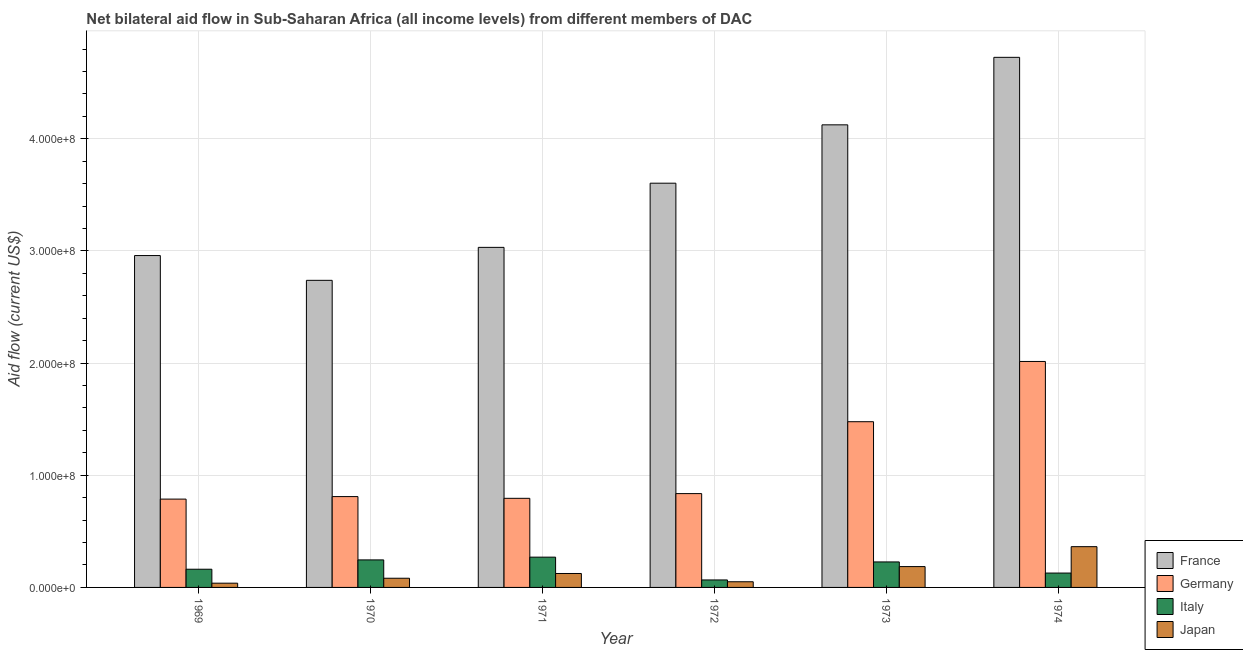How many groups of bars are there?
Provide a succinct answer. 6. Are the number of bars on each tick of the X-axis equal?
Give a very brief answer. Yes. How many bars are there on the 2nd tick from the left?
Ensure brevity in your answer.  4. What is the amount of aid given by germany in 1972?
Offer a terse response. 8.36e+07. Across all years, what is the maximum amount of aid given by japan?
Your answer should be very brief. 3.64e+07. Across all years, what is the minimum amount of aid given by japan?
Provide a succinct answer. 3.79e+06. In which year was the amount of aid given by germany maximum?
Give a very brief answer. 1974. In which year was the amount of aid given by italy minimum?
Keep it short and to the point. 1972. What is the total amount of aid given by germany in the graph?
Your answer should be compact. 6.72e+08. What is the difference between the amount of aid given by germany in 1972 and that in 1973?
Your answer should be compact. -6.41e+07. What is the difference between the amount of aid given by italy in 1971 and the amount of aid given by japan in 1970?
Your answer should be compact. 2.46e+06. What is the average amount of aid given by italy per year?
Provide a short and direct response. 1.83e+07. In the year 1969, what is the difference between the amount of aid given by italy and amount of aid given by germany?
Keep it short and to the point. 0. What is the ratio of the amount of aid given by italy in 1969 to that in 1970?
Provide a short and direct response. 0.66. Is the amount of aid given by france in 1970 less than that in 1972?
Give a very brief answer. Yes. What is the difference between the highest and the second highest amount of aid given by france?
Give a very brief answer. 6.02e+07. What is the difference between the highest and the lowest amount of aid given by japan?
Your response must be concise. 3.26e+07. In how many years, is the amount of aid given by italy greater than the average amount of aid given by italy taken over all years?
Provide a succinct answer. 3. What does the 3rd bar from the right in 1972 represents?
Your response must be concise. Germany. What is the difference between two consecutive major ticks on the Y-axis?
Your response must be concise. 1.00e+08. Are the values on the major ticks of Y-axis written in scientific E-notation?
Keep it short and to the point. Yes. Does the graph contain any zero values?
Offer a terse response. No. Where does the legend appear in the graph?
Your answer should be compact. Bottom right. How are the legend labels stacked?
Offer a very short reply. Vertical. What is the title of the graph?
Your response must be concise. Net bilateral aid flow in Sub-Saharan Africa (all income levels) from different members of DAC. Does "Fish species" appear as one of the legend labels in the graph?
Keep it short and to the point. No. What is the Aid flow (current US$) in France in 1969?
Make the answer very short. 2.96e+08. What is the Aid flow (current US$) in Germany in 1969?
Your answer should be compact. 7.88e+07. What is the Aid flow (current US$) of Italy in 1969?
Your response must be concise. 1.62e+07. What is the Aid flow (current US$) of Japan in 1969?
Provide a short and direct response. 3.79e+06. What is the Aid flow (current US$) of France in 1970?
Provide a short and direct response. 2.74e+08. What is the Aid flow (current US$) of Germany in 1970?
Keep it short and to the point. 8.10e+07. What is the Aid flow (current US$) in Italy in 1970?
Keep it short and to the point. 2.45e+07. What is the Aid flow (current US$) in Japan in 1970?
Your answer should be very brief. 8.19e+06. What is the Aid flow (current US$) of France in 1971?
Your answer should be very brief. 3.03e+08. What is the Aid flow (current US$) of Germany in 1971?
Ensure brevity in your answer.  7.94e+07. What is the Aid flow (current US$) in Italy in 1971?
Offer a very short reply. 2.70e+07. What is the Aid flow (current US$) in Japan in 1971?
Provide a succinct answer. 1.24e+07. What is the Aid flow (current US$) of France in 1972?
Provide a short and direct response. 3.60e+08. What is the Aid flow (current US$) in Germany in 1972?
Your response must be concise. 8.36e+07. What is the Aid flow (current US$) of Italy in 1972?
Your response must be concise. 6.67e+06. What is the Aid flow (current US$) in Japan in 1972?
Offer a terse response. 5.05e+06. What is the Aid flow (current US$) of France in 1973?
Your answer should be compact. 4.12e+08. What is the Aid flow (current US$) of Germany in 1973?
Give a very brief answer. 1.48e+08. What is the Aid flow (current US$) in Italy in 1973?
Make the answer very short. 2.27e+07. What is the Aid flow (current US$) in Japan in 1973?
Ensure brevity in your answer.  1.86e+07. What is the Aid flow (current US$) of France in 1974?
Ensure brevity in your answer.  4.73e+08. What is the Aid flow (current US$) in Germany in 1974?
Your answer should be very brief. 2.01e+08. What is the Aid flow (current US$) in Italy in 1974?
Your answer should be compact. 1.28e+07. What is the Aid flow (current US$) in Japan in 1974?
Provide a short and direct response. 3.64e+07. Across all years, what is the maximum Aid flow (current US$) of France?
Give a very brief answer. 4.73e+08. Across all years, what is the maximum Aid flow (current US$) of Germany?
Provide a succinct answer. 2.01e+08. Across all years, what is the maximum Aid flow (current US$) in Italy?
Your response must be concise. 2.70e+07. Across all years, what is the maximum Aid flow (current US$) of Japan?
Your response must be concise. 3.64e+07. Across all years, what is the minimum Aid flow (current US$) in France?
Give a very brief answer. 2.74e+08. Across all years, what is the minimum Aid flow (current US$) in Germany?
Ensure brevity in your answer.  7.88e+07. Across all years, what is the minimum Aid flow (current US$) of Italy?
Your response must be concise. 6.67e+06. Across all years, what is the minimum Aid flow (current US$) of Japan?
Offer a terse response. 3.79e+06. What is the total Aid flow (current US$) in France in the graph?
Keep it short and to the point. 2.12e+09. What is the total Aid flow (current US$) of Germany in the graph?
Offer a very short reply. 6.72e+08. What is the total Aid flow (current US$) of Italy in the graph?
Ensure brevity in your answer.  1.10e+08. What is the total Aid flow (current US$) in Japan in the graph?
Provide a short and direct response. 8.44e+07. What is the difference between the Aid flow (current US$) of France in 1969 and that in 1970?
Keep it short and to the point. 2.21e+07. What is the difference between the Aid flow (current US$) of Germany in 1969 and that in 1970?
Give a very brief answer. -2.25e+06. What is the difference between the Aid flow (current US$) of Italy in 1969 and that in 1970?
Offer a very short reply. -8.31e+06. What is the difference between the Aid flow (current US$) of Japan in 1969 and that in 1970?
Provide a short and direct response. -4.40e+06. What is the difference between the Aid flow (current US$) of France in 1969 and that in 1971?
Your answer should be very brief. -7.30e+06. What is the difference between the Aid flow (current US$) of Germany in 1969 and that in 1971?
Give a very brief answer. -7.00e+05. What is the difference between the Aid flow (current US$) in Italy in 1969 and that in 1971?
Make the answer very short. -1.08e+07. What is the difference between the Aid flow (current US$) in Japan in 1969 and that in 1971?
Offer a very short reply. -8.64e+06. What is the difference between the Aid flow (current US$) in France in 1969 and that in 1972?
Ensure brevity in your answer.  -6.45e+07. What is the difference between the Aid flow (current US$) of Germany in 1969 and that in 1972?
Your answer should be very brief. -4.90e+06. What is the difference between the Aid flow (current US$) in Italy in 1969 and that in 1972?
Provide a succinct answer. 9.56e+06. What is the difference between the Aid flow (current US$) in Japan in 1969 and that in 1972?
Your answer should be compact. -1.26e+06. What is the difference between the Aid flow (current US$) of France in 1969 and that in 1973?
Your answer should be compact. -1.17e+08. What is the difference between the Aid flow (current US$) of Germany in 1969 and that in 1973?
Offer a very short reply. -6.90e+07. What is the difference between the Aid flow (current US$) of Italy in 1969 and that in 1973?
Your answer should be very brief. -6.51e+06. What is the difference between the Aid flow (current US$) in Japan in 1969 and that in 1973?
Offer a terse response. -1.48e+07. What is the difference between the Aid flow (current US$) of France in 1969 and that in 1974?
Provide a short and direct response. -1.77e+08. What is the difference between the Aid flow (current US$) in Germany in 1969 and that in 1974?
Provide a short and direct response. -1.23e+08. What is the difference between the Aid flow (current US$) of Italy in 1969 and that in 1974?
Your answer should be very brief. 3.41e+06. What is the difference between the Aid flow (current US$) of Japan in 1969 and that in 1974?
Provide a short and direct response. -3.26e+07. What is the difference between the Aid flow (current US$) of France in 1970 and that in 1971?
Offer a very short reply. -2.94e+07. What is the difference between the Aid flow (current US$) of Germany in 1970 and that in 1971?
Provide a succinct answer. 1.55e+06. What is the difference between the Aid flow (current US$) of Italy in 1970 and that in 1971?
Offer a terse response. -2.46e+06. What is the difference between the Aid flow (current US$) in Japan in 1970 and that in 1971?
Give a very brief answer. -4.24e+06. What is the difference between the Aid flow (current US$) in France in 1970 and that in 1972?
Provide a succinct answer. -8.66e+07. What is the difference between the Aid flow (current US$) in Germany in 1970 and that in 1972?
Make the answer very short. -2.65e+06. What is the difference between the Aid flow (current US$) of Italy in 1970 and that in 1972?
Ensure brevity in your answer.  1.79e+07. What is the difference between the Aid flow (current US$) of Japan in 1970 and that in 1972?
Your response must be concise. 3.14e+06. What is the difference between the Aid flow (current US$) in France in 1970 and that in 1973?
Give a very brief answer. -1.39e+08. What is the difference between the Aid flow (current US$) in Germany in 1970 and that in 1973?
Your answer should be compact. -6.68e+07. What is the difference between the Aid flow (current US$) of Italy in 1970 and that in 1973?
Provide a succinct answer. 1.80e+06. What is the difference between the Aid flow (current US$) in Japan in 1970 and that in 1973?
Your response must be concise. -1.04e+07. What is the difference between the Aid flow (current US$) in France in 1970 and that in 1974?
Your response must be concise. -1.99e+08. What is the difference between the Aid flow (current US$) of Germany in 1970 and that in 1974?
Your answer should be very brief. -1.20e+08. What is the difference between the Aid flow (current US$) in Italy in 1970 and that in 1974?
Your answer should be compact. 1.17e+07. What is the difference between the Aid flow (current US$) in Japan in 1970 and that in 1974?
Provide a short and direct response. -2.82e+07. What is the difference between the Aid flow (current US$) of France in 1971 and that in 1972?
Your answer should be compact. -5.72e+07. What is the difference between the Aid flow (current US$) in Germany in 1971 and that in 1972?
Your answer should be very brief. -4.20e+06. What is the difference between the Aid flow (current US$) of Italy in 1971 and that in 1972?
Ensure brevity in your answer.  2.03e+07. What is the difference between the Aid flow (current US$) in Japan in 1971 and that in 1972?
Give a very brief answer. 7.38e+06. What is the difference between the Aid flow (current US$) in France in 1971 and that in 1973?
Offer a terse response. -1.09e+08. What is the difference between the Aid flow (current US$) of Germany in 1971 and that in 1973?
Make the answer very short. -6.83e+07. What is the difference between the Aid flow (current US$) in Italy in 1971 and that in 1973?
Your answer should be very brief. 4.26e+06. What is the difference between the Aid flow (current US$) of Japan in 1971 and that in 1973?
Your answer should be very brief. -6.15e+06. What is the difference between the Aid flow (current US$) in France in 1971 and that in 1974?
Give a very brief answer. -1.69e+08. What is the difference between the Aid flow (current US$) in Germany in 1971 and that in 1974?
Ensure brevity in your answer.  -1.22e+08. What is the difference between the Aid flow (current US$) in Italy in 1971 and that in 1974?
Give a very brief answer. 1.42e+07. What is the difference between the Aid flow (current US$) of Japan in 1971 and that in 1974?
Keep it short and to the point. -2.39e+07. What is the difference between the Aid flow (current US$) of France in 1972 and that in 1973?
Keep it short and to the point. -5.20e+07. What is the difference between the Aid flow (current US$) of Germany in 1972 and that in 1973?
Make the answer very short. -6.41e+07. What is the difference between the Aid flow (current US$) in Italy in 1972 and that in 1973?
Offer a very short reply. -1.61e+07. What is the difference between the Aid flow (current US$) in Japan in 1972 and that in 1973?
Ensure brevity in your answer.  -1.35e+07. What is the difference between the Aid flow (current US$) of France in 1972 and that in 1974?
Offer a very short reply. -1.12e+08. What is the difference between the Aid flow (current US$) of Germany in 1972 and that in 1974?
Make the answer very short. -1.18e+08. What is the difference between the Aid flow (current US$) in Italy in 1972 and that in 1974?
Provide a short and direct response. -6.15e+06. What is the difference between the Aid flow (current US$) in Japan in 1972 and that in 1974?
Give a very brief answer. -3.13e+07. What is the difference between the Aid flow (current US$) in France in 1973 and that in 1974?
Offer a terse response. -6.02e+07. What is the difference between the Aid flow (current US$) of Germany in 1973 and that in 1974?
Ensure brevity in your answer.  -5.37e+07. What is the difference between the Aid flow (current US$) in Italy in 1973 and that in 1974?
Provide a succinct answer. 9.92e+06. What is the difference between the Aid flow (current US$) of Japan in 1973 and that in 1974?
Keep it short and to the point. -1.78e+07. What is the difference between the Aid flow (current US$) in France in 1969 and the Aid flow (current US$) in Germany in 1970?
Make the answer very short. 2.15e+08. What is the difference between the Aid flow (current US$) of France in 1969 and the Aid flow (current US$) of Italy in 1970?
Give a very brief answer. 2.71e+08. What is the difference between the Aid flow (current US$) of France in 1969 and the Aid flow (current US$) of Japan in 1970?
Your answer should be very brief. 2.88e+08. What is the difference between the Aid flow (current US$) in Germany in 1969 and the Aid flow (current US$) in Italy in 1970?
Your response must be concise. 5.42e+07. What is the difference between the Aid flow (current US$) of Germany in 1969 and the Aid flow (current US$) of Japan in 1970?
Your response must be concise. 7.06e+07. What is the difference between the Aid flow (current US$) in Italy in 1969 and the Aid flow (current US$) in Japan in 1970?
Keep it short and to the point. 8.04e+06. What is the difference between the Aid flow (current US$) of France in 1969 and the Aid flow (current US$) of Germany in 1971?
Ensure brevity in your answer.  2.16e+08. What is the difference between the Aid flow (current US$) of France in 1969 and the Aid flow (current US$) of Italy in 1971?
Your answer should be compact. 2.69e+08. What is the difference between the Aid flow (current US$) in France in 1969 and the Aid flow (current US$) in Japan in 1971?
Offer a terse response. 2.83e+08. What is the difference between the Aid flow (current US$) in Germany in 1969 and the Aid flow (current US$) in Italy in 1971?
Provide a succinct answer. 5.18e+07. What is the difference between the Aid flow (current US$) in Germany in 1969 and the Aid flow (current US$) in Japan in 1971?
Your response must be concise. 6.63e+07. What is the difference between the Aid flow (current US$) of Italy in 1969 and the Aid flow (current US$) of Japan in 1971?
Offer a very short reply. 3.80e+06. What is the difference between the Aid flow (current US$) in France in 1969 and the Aid flow (current US$) in Germany in 1972?
Your answer should be compact. 2.12e+08. What is the difference between the Aid flow (current US$) in France in 1969 and the Aid flow (current US$) in Italy in 1972?
Your answer should be very brief. 2.89e+08. What is the difference between the Aid flow (current US$) of France in 1969 and the Aid flow (current US$) of Japan in 1972?
Provide a short and direct response. 2.91e+08. What is the difference between the Aid flow (current US$) in Germany in 1969 and the Aid flow (current US$) in Italy in 1972?
Make the answer very short. 7.21e+07. What is the difference between the Aid flow (current US$) of Germany in 1969 and the Aid flow (current US$) of Japan in 1972?
Provide a short and direct response. 7.37e+07. What is the difference between the Aid flow (current US$) of Italy in 1969 and the Aid flow (current US$) of Japan in 1972?
Keep it short and to the point. 1.12e+07. What is the difference between the Aid flow (current US$) in France in 1969 and the Aid flow (current US$) in Germany in 1973?
Your answer should be compact. 1.48e+08. What is the difference between the Aid flow (current US$) in France in 1969 and the Aid flow (current US$) in Italy in 1973?
Your answer should be compact. 2.73e+08. What is the difference between the Aid flow (current US$) in France in 1969 and the Aid flow (current US$) in Japan in 1973?
Offer a terse response. 2.77e+08. What is the difference between the Aid flow (current US$) of Germany in 1969 and the Aid flow (current US$) of Italy in 1973?
Give a very brief answer. 5.60e+07. What is the difference between the Aid flow (current US$) in Germany in 1969 and the Aid flow (current US$) in Japan in 1973?
Ensure brevity in your answer.  6.02e+07. What is the difference between the Aid flow (current US$) of Italy in 1969 and the Aid flow (current US$) of Japan in 1973?
Your answer should be very brief. -2.35e+06. What is the difference between the Aid flow (current US$) in France in 1969 and the Aid flow (current US$) in Germany in 1974?
Your response must be concise. 9.44e+07. What is the difference between the Aid flow (current US$) of France in 1969 and the Aid flow (current US$) of Italy in 1974?
Your answer should be compact. 2.83e+08. What is the difference between the Aid flow (current US$) in France in 1969 and the Aid flow (current US$) in Japan in 1974?
Your response must be concise. 2.60e+08. What is the difference between the Aid flow (current US$) of Germany in 1969 and the Aid flow (current US$) of Italy in 1974?
Offer a very short reply. 6.59e+07. What is the difference between the Aid flow (current US$) in Germany in 1969 and the Aid flow (current US$) in Japan in 1974?
Give a very brief answer. 4.24e+07. What is the difference between the Aid flow (current US$) in Italy in 1969 and the Aid flow (current US$) in Japan in 1974?
Make the answer very short. -2.01e+07. What is the difference between the Aid flow (current US$) of France in 1970 and the Aid flow (current US$) of Germany in 1971?
Provide a short and direct response. 1.94e+08. What is the difference between the Aid flow (current US$) of France in 1970 and the Aid flow (current US$) of Italy in 1971?
Keep it short and to the point. 2.47e+08. What is the difference between the Aid flow (current US$) in France in 1970 and the Aid flow (current US$) in Japan in 1971?
Offer a terse response. 2.61e+08. What is the difference between the Aid flow (current US$) of Germany in 1970 and the Aid flow (current US$) of Italy in 1971?
Ensure brevity in your answer.  5.40e+07. What is the difference between the Aid flow (current US$) in Germany in 1970 and the Aid flow (current US$) in Japan in 1971?
Ensure brevity in your answer.  6.86e+07. What is the difference between the Aid flow (current US$) in Italy in 1970 and the Aid flow (current US$) in Japan in 1971?
Offer a terse response. 1.21e+07. What is the difference between the Aid flow (current US$) in France in 1970 and the Aid flow (current US$) in Germany in 1972?
Provide a short and direct response. 1.90e+08. What is the difference between the Aid flow (current US$) of France in 1970 and the Aid flow (current US$) of Italy in 1972?
Offer a terse response. 2.67e+08. What is the difference between the Aid flow (current US$) in France in 1970 and the Aid flow (current US$) in Japan in 1972?
Your answer should be very brief. 2.69e+08. What is the difference between the Aid flow (current US$) of Germany in 1970 and the Aid flow (current US$) of Italy in 1972?
Give a very brief answer. 7.43e+07. What is the difference between the Aid flow (current US$) of Germany in 1970 and the Aid flow (current US$) of Japan in 1972?
Offer a terse response. 7.60e+07. What is the difference between the Aid flow (current US$) of Italy in 1970 and the Aid flow (current US$) of Japan in 1972?
Offer a terse response. 1.95e+07. What is the difference between the Aid flow (current US$) in France in 1970 and the Aid flow (current US$) in Germany in 1973?
Give a very brief answer. 1.26e+08. What is the difference between the Aid flow (current US$) of France in 1970 and the Aid flow (current US$) of Italy in 1973?
Offer a terse response. 2.51e+08. What is the difference between the Aid flow (current US$) in France in 1970 and the Aid flow (current US$) in Japan in 1973?
Provide a succinct answer. 2.55e+08. What is the difference between the Aid flow (current US$) of Germany in 1970 and the Aid flow (current US$) of Italy in 1973?
Give a very brief answer. 5.83e+07. What is the difference between the Aid flow (current US$) in Germany in 1970 and the Aid flow (current US$) in Japan in 1973?
Your answer should be very brief. 6.24e+07. What is the difference between the Aid flow (current US$) of Italy in 1970 and the Aid flow (current US$) of Japan in 1973?
Your response must be concise. 5.96e+06. What is the difference between the Aid flow (current US$) in France in 1970 and the Aid flow (current US$) in Germany in 1974?
Provide a short and direct response. 7.23e+07. What is the difference between the Aid flow (current US$) of France in 1970 and the Aid flow (current US$) of Italy in 1974?
Make the answer very short. 2.61e+08. What is the difference between the Aid flow (current US$) in France in 1970 and the Aid flow (current US$) in Japan in 1974?
Keep it short and to the point. 2.37e+08. What is the difference between the Aid flow (current US$) of Germany in 1970 and the Aid flow (current US$) of Italy in 1974?
Provide a short and direct response. 6.82e+07. What is the difference between the Aid flow (current US$) in Germany in 1970 and the Aid flow (current US$) in Japan in 1974?
Give a very brief answer. 4.46e+07. What is the difference between the Aid flow (current US$) of Italy in 1970 and the Aid flow (current US$) of Japan in 1974?
Your response must be concise. -1.18e+07. What is the difference between the Aid flow (current US$) of France in 1971 and the Aid flow (current US$) of Germany in 1972?
Your response must be concise. 2.20e+08. What is the difference between the Aid flow (current US$) of France in 1971 and the Aid flow (current US$) of Italy in 1972?
Provide a succinct answer. 2.97e+08. What is the difference between the Aid flow (current US$) in France in 1971 and the Aid flow (current US$) in Japan in 1972?
Keep it short and to the point. 2.98e+08. What is the difference between the Aid flow (current US$) of Germany in 1971 and the Aid flow (current US$) of Italy in 1972?
Keep it short and to the point. 7.28e+07. What is the difference between the Aid flow (current US$) in Germany in 1971 and the Aid flow (current US$) in Japan in 1972?
Your answer should be very brief. 7.44e+07. What is the difference between the Aid flow (current US$) of Italy in 1971 and the Aid flow (current US$) of Japan in 1972?
Your answer should be compact. 2.20e+07. What is the difference between the Aid flow (current US$) of France in 1971 and the Aid flow (current US$) of Germany in 1973?
Give a very brief answer. 1.55e+08. What is the difference between the Aid flow (current US$) of France in 1971 and the Aid flow (current US$) of Italy in 1973?
Provide a succinct answer. 2.80e+08. What is the difference between the Aid flow (current US$) in France in 1971 and the Aid flow (current US$) in Japan in 1973?
Provide a succinct answer. 2.85e+08. What is the difference between the Aid flow (current US$) of Germany in 1971 and the Aid flow (current US$) of Italy in 1973?
Your answer should be compact. 5.67e+07. What is the difference between the Aid flow (current US$) of Germany in 1971 and the Aid flow (current US$) of Japan in 1973?
Give a very brief answer. 6.09e+07. What is the difference between the Aid flow (current US$) in Italy in 1971 and the Aid flow (current US$) in Japan in 1973?
Make the answer very short. 8.42e+06. What is the difference between the Aid flow (current US$) in France in 1971 and the Aid flow (current US$) in Germany in 1974?
Make the answer very short. 1.02e+08. What is the difference between the Aid flow (current US$) of France in 1971 and the Aid flow (current US$) of Italy in 1974?
Make the answer very short. 2.90e+08. What is the difference between the Aid flow (current US$) of France in 1971 and the Aid flow (current US$) of Japan in 1974?
Provide a short and direct response. 2.67e+08. What is the difference between the Aid flow (current US$) in Germany in 1971 and the Aid flow (current US$) in Italy in 1974?
Give a very brief answer. 6.66e+07. What is the difference between the Aid flow (current US$) of Germany in 1971 and the Aid flow (current US$) of Japan in 1974?
Offer a terse response. 4.31e+07. What is the difference between the Aid flow (current US$) in Italy in 1971 and the Aid flow (current US$) in Japan in 1974?
Offer a terse response. -9.35e+06. What is the difference between the Aid flow (current US$) in France in 1972 and the Aid flow (current US$) in Germany in 1973?
Keep it short and to the point. 2.13e+08. What is the difference between the Aid flow (current US$) in France in 1972 and the Aid flow (current US$) in Italy in 1973?
Offer a terse response. 3.38e+08. What is the difference between the Aid flow (current US$) of France in 1972 and the Aid flow (current US$) of Japan in 1973?
Offer a terse response. 3.42e+08. What is the difference between the Aid flow (current US$) of Germany in 1972 and the Aid flow (current US$) of Italy in 1973?
Provide a short and direct response. 6.09e+07. What is the difference between the Aid flow (current US$) in Germany in 1972 and the Aid flow (current US$) in Japan in 1973?
Ensure brevity in your answer.  6.51e+07. What is the difference between the Aid flow (current US$) of Italy in 1972 and the Aid flow (current US$) of Japan in 1973?
Offer a terse response. -1.19e+07. What is the difference between the Aid flow (current US$) of France in 1972 and the Aid flow (current US$) of Germany in 1974?
Ensure brevity in your answer.  1.59e+08. What is the difference between the Aid flow (current US$) of France in 1972 and the Aid flow (current US$) of Italy in 1974?
Your answer should be very brief. 3.48e+08. What is the difference between the Aid flow (current US$) of France in 1972 and the Aid flow (current US$) of Japan in 1974?
Keep it short and to the point. 3.24e+08. What is the difference between the Aid flow (current US$) in Germany in 1972 and the Aid flow (current US$) in Italy in 1974?
Make the answer very short. 7.08e+07. What is the difference between the Aid flow (current US$) of Germany in 1972 and the Aid flow (current US$) of Japan in 1974?
Ensure brevity in your answer.  4.73e+07. What is the difference between the Aid flow (current US$) of Italy in 1972 and the Aid flow (current US$) of Japan in 1974?
Make the answer very short. -2.97e+07. What is the difference between the Aid flow (current US$) of France in 1973 and the Aid flow (current US$) of Germany in 1974?
Provide a short and direct response. 2.11e+08. What is the difference between the Aid flow (current US$) in France in 1973 and the Aid flow (current US$) in Italy in 1974?
Give a very brief answer. 4.00e+08. What is the difference between the Aid flow (current US$) in France in 1973 and the Aid flow (current US$) in Japan in 1974?
Provide a succinct answer. 3.76e+08. What is the difference between the Aid flow (current US$) of Germany in 1973 and the Aid flow (current US$) of Italy in 1974?
Keep it short and to the point. 1.35e+08. What is the difference between the Aid flow (current US$) of Germany in 1973 and the Aid flow (current US$) of Japan in 1974?
Your answer should be compact. 1.11e+08. What is the difference between the Aid flow (current US$) of Italy in 1973 and the Aid flow (current US$) of Japan in 1974?
Give a very brief answer. -1.36e+07. What is the average Aid flow (current US$) in France per year?
Your answer should be compact. 3.53e+08. What is the average Aid flow (current US$) in Germany per year?
Your response must be concise. 1.12e+08. What is the average Aid flow (current US$) in Italy per year?
Your answer should be very brief. 1.83e+07. What is the average Aid flow (current US$) of Japan per year?
Offer a very short reply. 1.41e+07. In the year 1969, what is the difference between the Aid flow (current US$) of France and Aid flow (current US$) of Germany?
Your response must be concise. 2.17e+08. In the year 1969, what is the difference between the Aid flow (current US$) of France and Aid flow (current US$) of Italy?
Offer a terse response. 2.80e+08. In the year 1969, what is the difference between the Aid flow (current US$) of France and Aid flow (current US$) of Japan?
Give a very brief answer. 2.92e+08. In the year 1969, what is the difference between the Aid flow (current US$) in Germany and Aid flow (current US$) in Italy?
Your response must be concise. 6.25e+07. In the year 1969, what is the difference between the Aid flow (current US$) of Germany and Aid flow (current US$) of Japan?
Provide a short and direct response. 7.50e+07. In the year 1969, what is the difference between the Aid flow (current US$) in Italy and Aid flow (current US$) in Japan?
Ensure brevity in your answer.  1.24e+07. In the year 1970, what is the difference between the Aid flow (current US$) in France and Aid flow (current US$) in Germany?
Your response must be concise. 1.93e+08. In the year 1970, what is the difference between the Aid flow (current US$) of France and Aid flow (current US$) of Italy?
Keep it short and to the point. 2.49e+08. In the year 1970, what is the difference between the Aid flow (current US$) in France and Aid flow (current US$) in Japan?
Your response must be concise. 2.66e+08. In the year 1970, what is the difference between the Aid flow (current US$) of Germany and Aid flow (current US$) of Italy?
Make the answer very short. 5.65e+07. In the year 1970, what is the difference between the Aid flow (current US$) in Germany and Aid flow (current US$) in Japan?
Your response must be concise. 7.28e+07. In the year 1970, what is the difference between the Aid flow (current US$) in Italy and Aid flow (current US$) in Japan?
Keep it short and to the point. 1.64e+07. In the year 1971, what is the difference between the Aid flow (current US$) in France and Aid flow (current US$) in Germany?
Provide a succinct answer. 2.24e+08. In the year 1971, what is the difference between the Aid flow (current US$) of France and Aid flow (current US$) of Italy?
Your answer should be very brief. 2.76e+08. In the year 1971, what is the difference between the Aid flow (current US$) of France and Aid flow (current US$) of Japan?
Provide a short and direct response. 2.91e+08. In the year 1971, what is the difference between the Aid flow (current US$) in Germany and Aid flow (current US$) in Italy?
Offer a terse response. 5.24e+07. In the year 1971, what is the difference between the Aid flow (current US$) in Germany and Aid flow (current US$) in Japan?
Provide a short and direct response. 6.70e+07. In the year 1971, what is the difference between the Aid flow (current US$) of Italy and Aid flow (current US$) of Japan?
Your response must be concise. 1.46e+07. In the year 1972, what is the difference between the Aid flow (current US$) in France and Aid flow (current US$) in Germany?
Provide a short and direct response. 2.77e+08. In the year 1972, what is the difference between the Aid flow (current US$) of France and Aid flow (current US$) of Italy?
Keep it short and to the point. 3.54e+08. In the year 1972, what is the difference between the Aid flow (current US$) in France and Aid flow (current US$) in Japan?
Offer a very short reply. 3.55e+08. In the year 1972, what is the difference between the Aid flow (current US$) of Germany and Aid flow (current US$) of Italy?
Ensure brevity in your answer.  7.70e+07. In the year 1972, what is the difference between the Aid flow (current US$) of Germany and Aid flow (current US$) of Japan?
Make the answer very short. 7.86e+07. In the year 1972, what is the difference between the Aid flow (current US$) in Italy and Aid flow (current US$) in Japan?
Provide a short and direct response. 1.62e+06. In the year 1973, what is the difference between the Aid flow (current US$) of France and Aid flow (current US$) of Germany?
Your answer should be compact. 2.65e+08. In the year 1973, what is the difference between the Aid flow (current US$) in France and Aid flow (current US$) in Italy?
Ensure brevity in your answer.  3.90e+08. In the year 1973, what is the difference between the Aid flow (current US$) of France and Aid flow (current US$) of Japan?
Keep it short and to the point. 3.94e+08. In the year 1973, what is the difference between the Aid flow (current US$) of Germany and Aid flow (current US$) of Italy?
Provide a succinct answer. 1.25e+08. In the year 1973, what is the difference between the Aid flow (current US$) of Germany and Aid flow (current US$) of Japan?
Provide a short and direct response. 1.29e+08. In the year 1973, what is the difference between the Aid flow (current US$) of Italy and Aid flow (current US$) of Japan?
Make the answer very short. 4.16e+06. In the year 1974, what is the difference between the Aid flow (current US$) in France and Aid flow (current US$) in Germany?
Provide a short and direct response. 2.71e+08. In the year 1974, what is the difference between the Aid flow (current US$) in France and Aid flow (current US$) in Italy?
Provide a short and direct response. 4.60e+08. In the year 1974, what is the difference between the Aid flow (current US$) in France and Aid flow (current US$) in Japan?
Ensure brevity in your answer.  4.36e+08. In the year 1974, what is the difference between the Aid flow (current US$) in Germany and Aid flow (current US$) in Italy?
Offer a very short reply. 1.89e+08. In the year 1974, what is the difference between the Aid flow (current US$) of Germany and Aid flow (current US$) of Japan?
Provide a succinct answer. 1.65e+08. In the year 1974, what is the difference between the Aid flow (current US$) in Italy and Aid flow (current US$) in Japan?
Your answer should be very brief. -2.35e+07. What is the ratio of the Aid flow (current US$) in France in 1969 to that in 1970?
Your answer should be compact. 1.08. What is the ratio of the Aid flow (current US$) in Germany in 1969 to that in 1970?
Provide a succinct answer. 0.97. What is the ratio of the Aid flow (current US$) in Italy in 1969 to that in 1970?
Your answer should be compact. 0.66. What is the ratio of the Aid flow (current US$) in Japan in 1969 to that in 1970?
Make the answer very short. 0.46. What is the ratio of the Aid flow (current US$) of France in 1969 to that in 1971?
Give a very brief answer. 0.98. What is the ratio of the Aid flow (current US$) in Italy in 1969 to that in 1971?
Offer a terse response. 0.6. What is the ratio of the Aid flow (current US$) of Japan in 1969 to that in 1971?
Your answer should be compact. 0.3. What is the ratio of the Aid flow (current US$) of France in 1969 to that in 1972?
Offer a very short reply. 0.82. What is the ratio of the Aid flow (current US$) of Germany in 1969 to that in 1972?
Provide a succinct answer. 0.94. What is the ratio of the Aid flow (current US$) in Italy in 1969 to that in 1972?
Make the answer very short. 2.43. What is the ratio of the Aid flow (current US$) in Japan in 1969 to that in 1972?
Offer a terse response. 0.75. What is the ratio of the Aid flow (current US$) in France in 1969 to that in 1973?
Your answer should be very brief. 0.72. What is the ratio of the Aid flow (current US$) in Germany in 1969 to that in 1973?
Offer a terse response. 0.53. What is the ratio of the Aid flow (current US$) in Italy in 1969 to that in 1973?
Provide a succinct answer. 0.71. What is the ratio of the Aid flow (current US$) in Japan in 1969 to that in 1973?
Give a very brief answer. 0.2. What is the ratio of the Aid flow (current US$) of France in 1969 to that in 1974?
Ensure brevity in your answer.  0.63. What is the ratio of the Aid flow (current US$) in Germany in 1969 to that in 1974?
Your answer should be compact. 0.39. What is the ratio of the Aid flow (current US$) of Italy in 1969 to that in 1974?
Provide a short and direct response. 1.27. What is the ratio of the Aid flow (current US$) in Japan in 1969 to that in 1974?
Your response must be concise. 0.1. What is the ratio of the Aid flow (current US$) of France in 1970 to that in 1971?
Ensure brevity in your answer.  0.9. What is the ratio of the Aid flow (current US$) of Germany in 1970 to that in 1971?
Ensure brevity in your answer.  1.02. What is the ratio of the Aid flow (current US$) of Italy in 1970 to that in 1971?
Provide a succinct answer. 0.91. What is the ratio of the Aid flow (current US$) in Japan in 1970 to that in 1971?
Provide a succinct answer. 0.66. What is the ratio of the Aid flow (current US$) in France in 1970 to that in 1972?
Provide a succinct answer. 0.76. What is the ratio of the Aid flow (current US$) in Germany in 1970 to that in 1972?
Your answer should be very brief. 0.97. What is the ratio of the Aid flow (current US$) in Italy in 1970 to that in 1972?
Give a very brief answer. 3.68. What is the ratio of the Aid flow (current US$) in Japan in 1970 to that in 1972?
Offer a very short reply. 1.62. What is the ratio of the Aid flow (current US$) of France in 1970 to that in 1973?
Offer a terse response. 0.66. What is the ratio of the Aid flow (current US$) in Germany in 1970 to that in 1973?
Offer a terse response. 0.55. What is the ratio of the Aid flow (current US$) of Italy in 1970 to that in 1973?
Your answer should be compact. 1.08. What is the ratio of the Aid flow (current US$) of Japan in 1970 to that in 1973?
Your answer should be very brief. 0.44. What is the ratio of the Aid flow (current US$) in France in 1970 to that in 1974?
Make the answer very short. 0.58. What is the ratio of the Aid flow (current US$) of Germany in 1970 to that in 1974?
Offer a very short reply. 0.4. What is the ratio of the Aid flow (current US$) in Italy in 1970 to that in 1974?
Make the answer very short. 1.91. What is the ratio of the Aid flow (current US$) of Japan in 1970 to that in 1974?
Give a very brief answer. 0.23. What is the ratio of the Aid flow (current US$) of France in 1971 to that in 1972?
Keep it short and to the point. 0.84. What is the ratio of the Aid flow (current US$) in Germany in 1971 to that in 1972?
Offer a very short reply. 0.95. What is the ratio of the Aid flow (current US$) of Italy in 1971 to that in 1972?
Your response must be concise. 4.05. What is the ratio of the Aid flow (current US$) in Japan in 1971 to that in 1972?
Your response must be concise. 2.46. What is the ratio of the Aid flow (current US$) in France in 1971 to that in 1973?
Your answer should be compact. 0.74. What is the ratio of the Aid flow (current US$) of Germany in 1971 to that in 1973?
Offer a terse response. 0.54. What is the ratio of the Aid flow (current US$) in Italy in 1971 to that in 1973?
Offer a very short reply. 1.19. What is the ratio of the Aid flow (current US$) in Japan in 1971 to that in 1973?
Offer a very short reply. 0.67. What is the ratio of the Aid flow (current US$) of France in 1971 to that in 1974?
Give a very brief answer. 0.64. What is the ratio of the Aid flow (current US$) of Germany in 1971 to that in 1974?
Provide a short and direct response. 0.39. What is the ratio of the Aid flow (current US$) of Italy in 1971 to that in 1974?
Offer a terse response. 2.11. What is the ratio of the Aid flow (current US$) of Japan in 1971 to that in 1974?
Provide a short and direct response. 0.34. What is the ratio of the Aid flow (current US$) in France in 1972 to that in 1973?
Keep it short and to the point. 0.87. What is the ratio of the Aid flow (current US$) of Germany in 1972 to that in 1973?
Offer a terse response. 0.57. What is the ratio of the Aid flow (current US$) of Italy in 1972 to that in 1973?
Provide a succinct answer. 0.29. What is the ratio of the Aid flow (current US$) in Japan in 1972 to that in 1973?
Keep it short and to the point. 0.27. What is the ratio of the Aid flow (current US$) of France in 1972 to that in 1974?
Your answer should be compact. 0.76. What is the ratio of the Aid flow (current US$) of Germany in 1972 to that in 1974?
Your answer should be very brief. 0.42. What is the ratio of the Aid flow (current US$) in Italy in 1972 to that in 1974?
Provide a succinct answer. 0.52. What is the ratio of the Aid flow (current US$) in Japan in 1972 to that in 1974?
Your answer should be very brief. 0.14. What is the ratio of the Aid flow (current US$) in France in 1973 to that in 1974?
Provide a short and direct response. 0.87. What is the ratio of the Aid flow (current US$) in Germany in 1973 to that in 1974?
Your answer should be very brief. 0.73. What is the ratio of the Aid flow (current US$) of Italy in 1973 to that in 1974?
Your response must be concise. 1.77. What is the ratio of the Aid flow (current US$) of Japan in 1973 to that in 1974?
Your response must be concise. 0.51. What is the difference between the highest and the second highest Aid flow (current US$) of France?
Give a very brief answer. 6.02e+07. What is the difference between the highest and the second highest Aid flow (current US$) in Germany?
Offer a terse response. 5.37e+07. What is the difference between the highest and the second highest Aid flow (current US$) in Italy?
Provide a succinct answer. 2.46e+06. What is the difference between the highest and the second highest Aid flow (current US$) in Japan?
Provide a short and direct response. 1.78e+07. What is the difference between the highest and the lowest Aid flow (current US$) of France?
Give a very brief answer. 1.99e+08. What is the difference between the highest and the lowest Aid flow (current US$) in Germany?
Offer a terse response. 1.23e+08. What is the difference between the highest and the lowest Aid flow (current US$) in Italy?
Ensure brevity in your answer.  2.03e+07. What is the difference between the highest and the lowest Aid flow (current US$) in Japan?
Offer a terse response. 3.26e+07. 